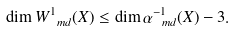Convert formula to latex. <formula><loc_0><loc_0><loc_500><loc_500>\dim W ^ { 1 } _ { \ m d } ( X ) \leq \dim \alpha _ { \ m d } ^ { - 1 } ( X ) - 3 .</formula> 